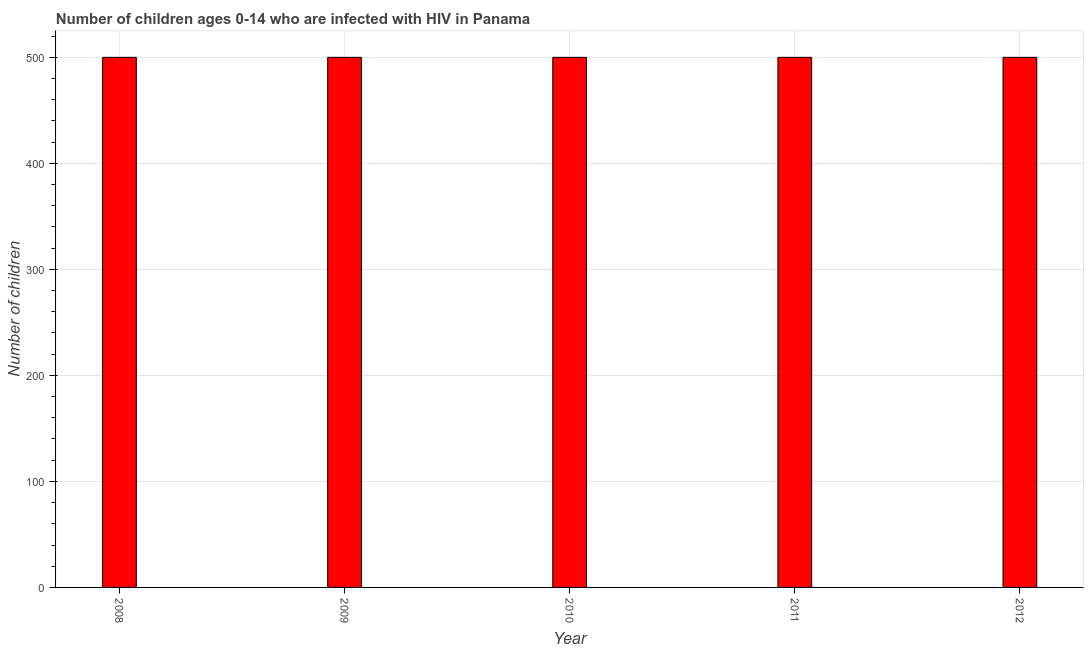Does the graph contain any zero values?
Offer a terse response. No. What is the title of the graph?
Keep it short and to the point. Number of children ages 0-14 who are infected with HIV in Panama. What is the label or title of the Y-axis?
Provide a succinct answer. Number of children. In which year was the number of children living with hiv maximum?
Offer a very short reply. 2008. What is the sum of the number of children living with hiv?
Provide a short and direct response. 2500. In how many years, is the number of children living with hiv greater than 120 ?
Give a very brief answer. 5. Do a majority of the years between 2010 and 2012 (inclusive) have number of children living with hiv greater than 420 ?
Give a very brief answer. Yes. How many bars are there?
Provide a short and direct response. 5. Are the values on the major ticks of Y-axis written in scientific E-notation?
Ensure brevity in your answer.  No. What is the Number of children of 2008?
Your response must be concise. 500. What is the Number of children in 2009?
Keep it short and to the point. 500. What is the Number of children in 2011?
Your answer should be compact. 500. What is the difference between the Number of children in 2008 and 2010?
Your response must be concise. 0. What is the difference between the Number of children in 2009 and 2011?
Your response must be concise. 0. What is the difference between the Number of children in 2010 and 2011?
Your response must be concise. 0. What is the difference between the Number of children in 2011 and 2012?
Provide a succinct answer. 0. What is the ratio of the Number of children in 2008 to that in 2010?
Provide a succinct answer. 1. What is the ratio of the Number of children in 2008 to that in 2011?
Keep it short and to the point. 1. What is the ratio of the Number of children in 2009 to that in 2012?
Offer a terse response. 1. What is the ratio of the Number of children in 2010 to that in 2011?
Offer a terse response. 1. What is the ratio of the Number of children in 2010 to that in 2012?
Your answer should be very brief. 1. 